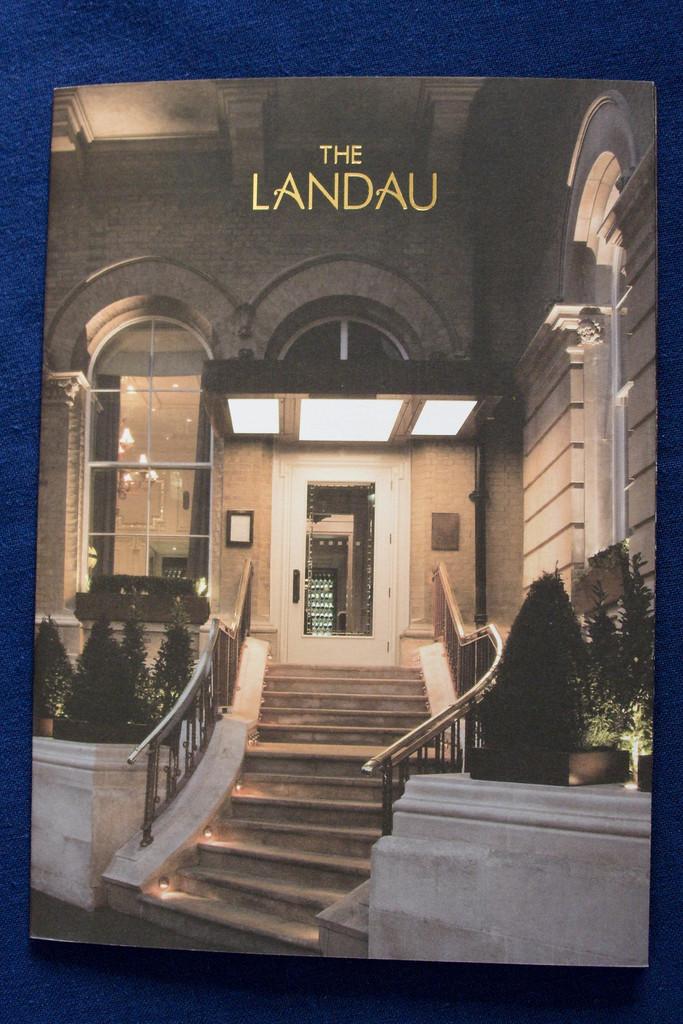What is the name of this building?
Ensure brevity in your answer.  The landau. 